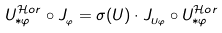Convert formula to latex. <formula><loc_0><loc_0><loc_500><loc_500>U _ { \ast \varphi } ^ { \mathcal { H } o r } \circ J _ { _ { \varphi } } = \sigma ( U ) \cdot J _ { _ { U \varphi } } \circ U _ { \ast \varphi } ^ { \mathcal { H } o r }</formula> 